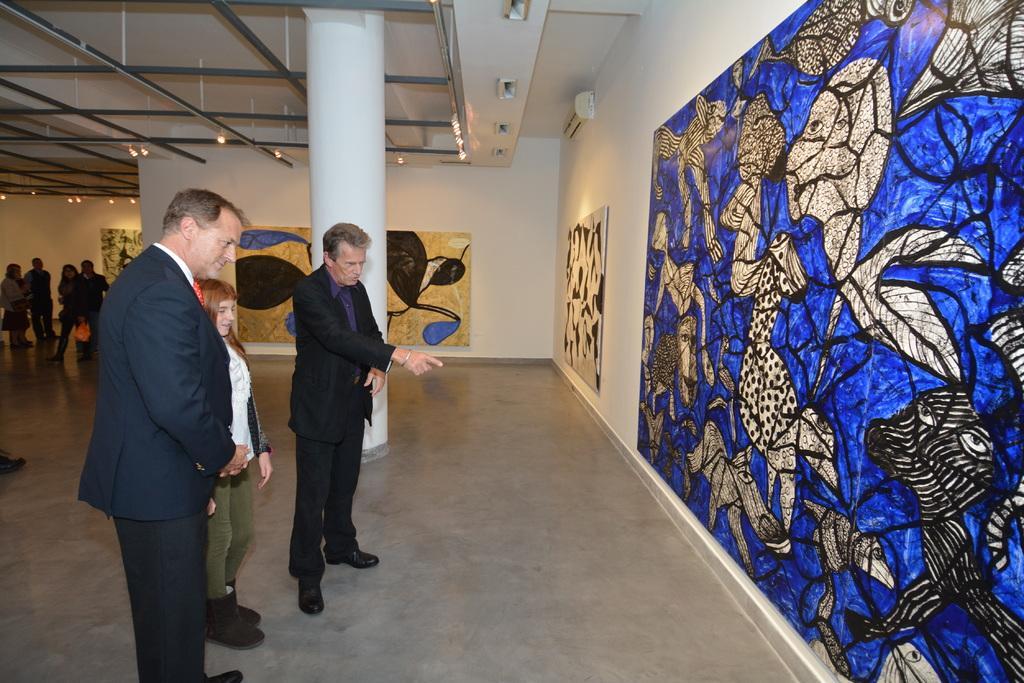Describe this image in one or two sentences. In this image I can see a group of people are standing on the floor. In the background I can see a wall, wall paintings, metal rods and lights. This image is taken may be in a hall. 